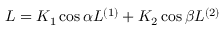Convert formula to latex. <formula><loc_0><loc_0><loc_500><loc_500>L = K _ { 1 } \cos \alpha L ^ { ( 1 ) } + K _ { 2 } \cos \beta L ^ { ( 2 ) }</formula> 